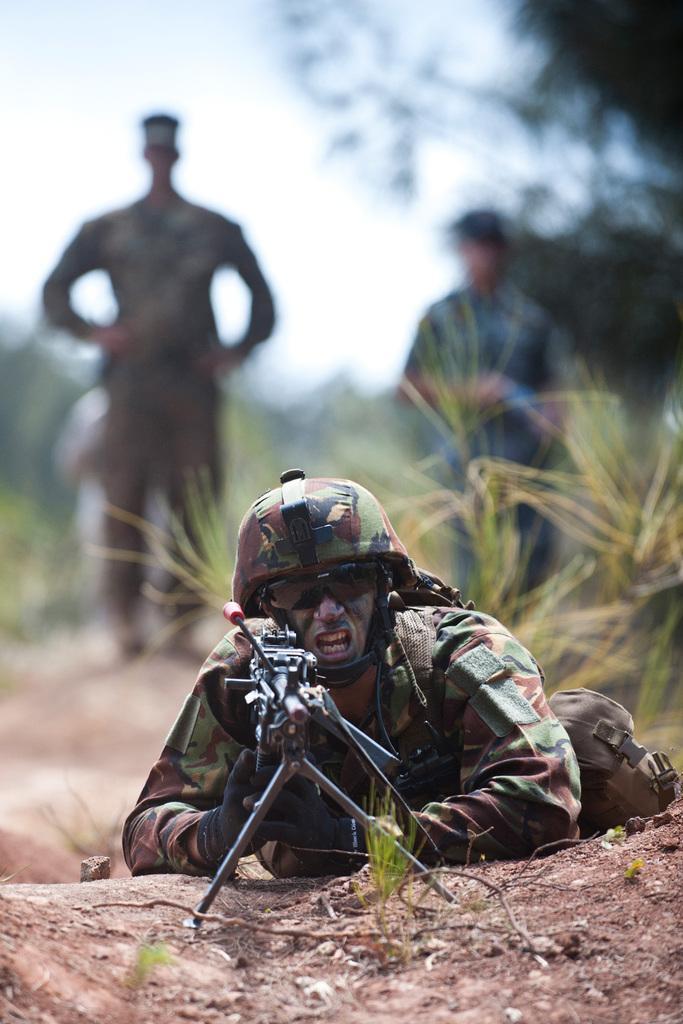Can you describe this image briefly? In this picture there is a army man who is lying on the ground. He is wearing helmet, goggles, shirt, trouser and shoe. He is holding a machine gun. In the background there are two persons standing on the ground. On the top left there is a sky. On the top right there is a tree. Here we can see grass. 